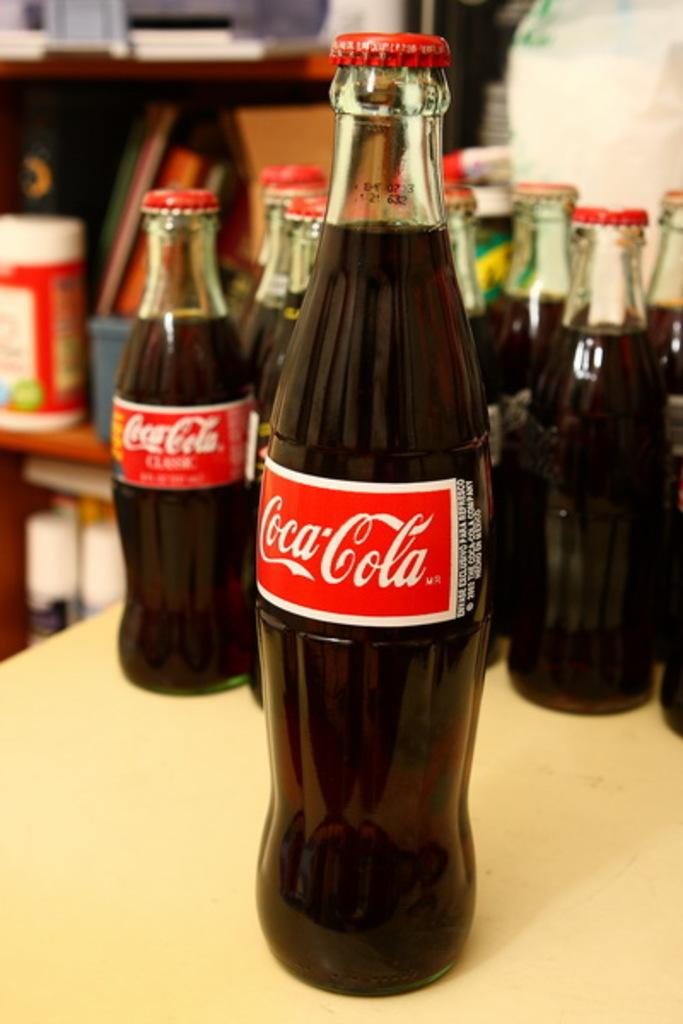What is on the bottles in the image? The bottles have stickers on them in the image. Where are the bottles located? The bottles are placed on a table. What can be seen in the background of the image? There are wooden sticks and racks visible in the background of the image. Can you describe the person in the background? There is a person in the background of the image, but no specific details are provided. What type of chicken is being served in the image? There is no chicken present in the image; it features bottles with stickers on a table. What flavor of soda is in the bottles? The image does not specify the flavor of soda in the bottles, as it only shows stickers on the bottles. 